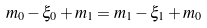<formula> <loc_0><loc_0><loc_500><loc_500>m _ { 0 } - \xi _ { 0 } + m _ { 1 } = m _ { 1 } - \xi _ { 1 } + m _ { 0 }</formula> 